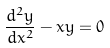<formula> <loc_0><loc_0><loc_500><loc_500>\frac { d ^ { 2 } y } { d x ^ { 2 } } - x y = 0</formula> 